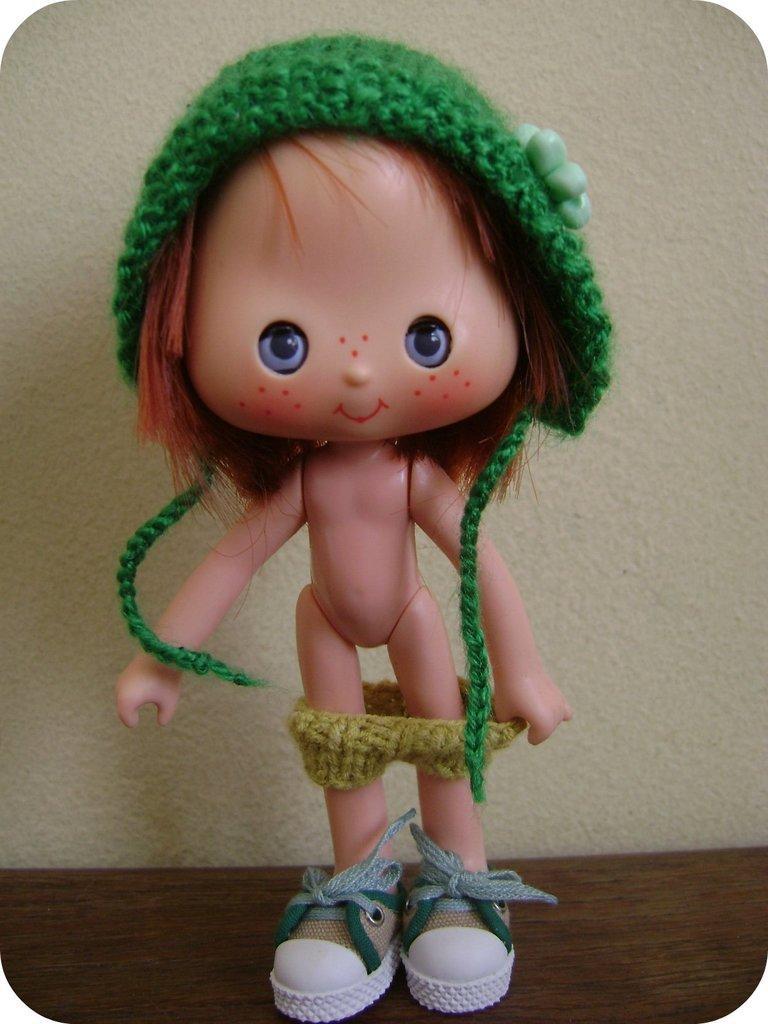Can you describe this image briefly? In this image I can see a doll which is brown in color is wearing a cap which is green in color and shoes which are white and green in color is on the brown colored surface. I can see the cream colored background. 